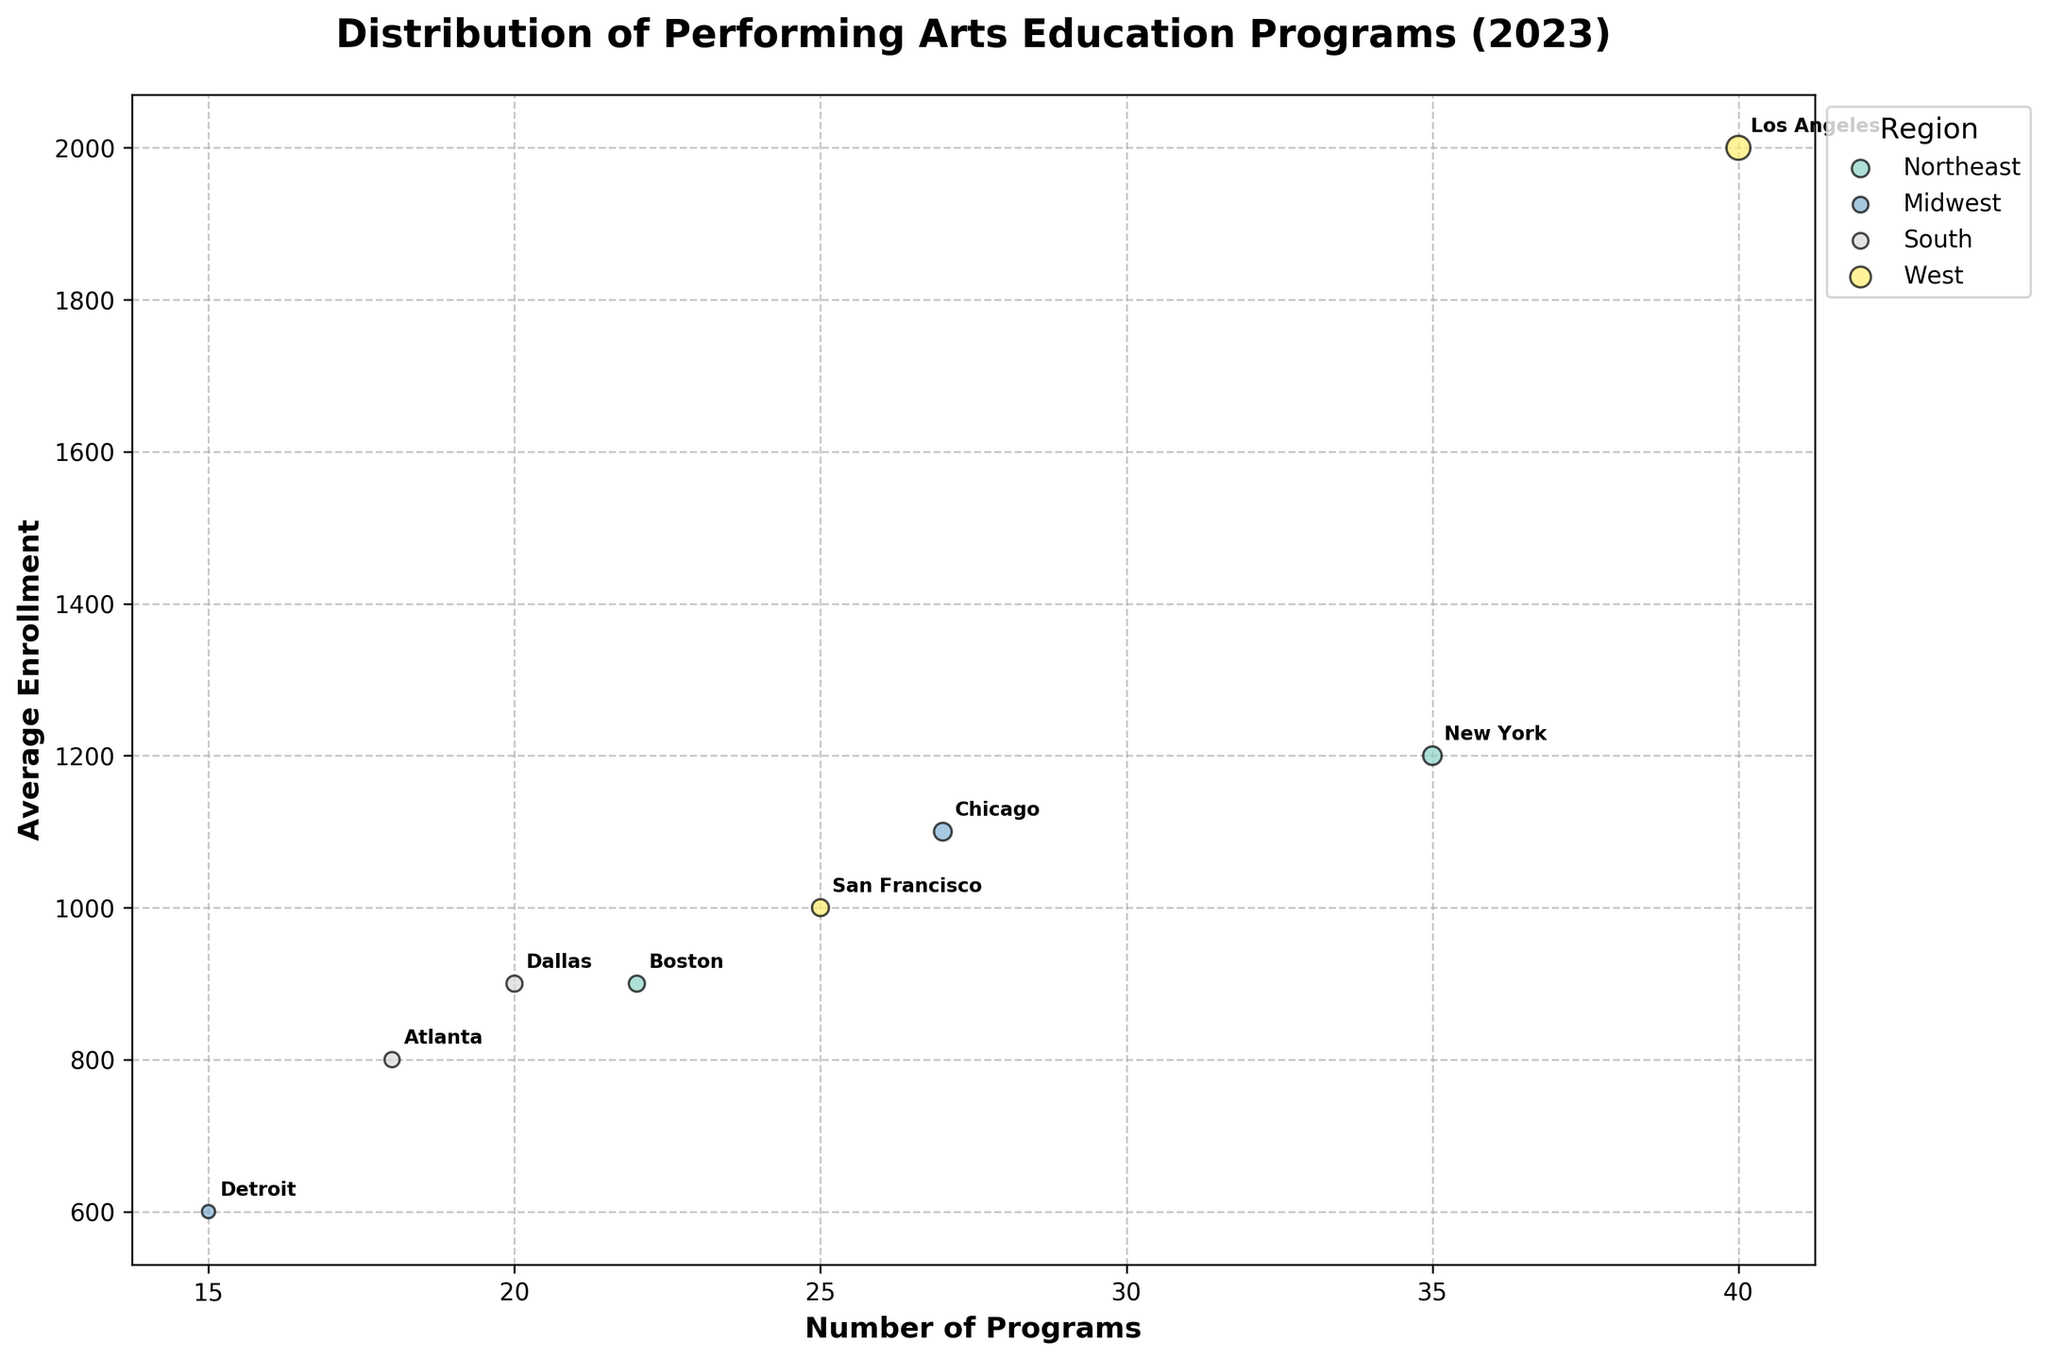what is the title of the plot? The title of the plot is typically printed on the top of the figure. For this plot, the title is located at the top center and reads "Distribution of Performing Arts Education Programs (2023)".
Answer: Distribution of Performing Arts Education Programs (2023) What are the axes labeled as? The x-axis is labeled as the "Number of Programs", and the y-axis is labeled as the "Average Enrollment". This information helps in interpreting what each axis represents.
Answer: Number of Programs, Average Enrollment Which city in the West region has the highest average enrollment? In the West region, there are two cities: Los Angeles and San Francisco. The average enrollment for Los Angeles is 2000, while for San Francisco, it is 1000. Therefore, Los Angeles has the highest average enrollment.
Answer: Los Angeles How many programs are in Boston, and what's the average enrollment? In the figure, Boston is annotated. By checking the position of the annotation related to its corresponding point, Boston has 22 programs and an average enrollment of 900.
Answer: 22 programs, 900 enrollment Which region has the city with the most significant number of programs? To find which region has the city with the most significant number of programs, compare the number of programs for each city. Los Angeles in the West region has the most programs, with 40.
Answer: West What is the total number of programs in the Northeast region? The cities in the Northeast region are New York and Boston. New York has 35 programs, and Boston has 22 programs. Therefore, the total number of programs in the Northeast region is 35 + 22 = 57.
Answer: 57 Which two cities have the closest average enrollment? By comparing the average enrollment values: New York (1200), Boston (900), Chicago (1100), Detroit (600), Atlanta (800), Dallas (900), Los Angeles (2000), San Francisco (1000), Boston and Dallas both have the average enrollment of 900.
Answer: Boston and Dallas What is the difference in average enrollment between New York and Detroit? New York has an average enrollment of 1200, whereas Detroit has an average enrollment of 600. The difference is calculated as 1200 - 600 = 600.
Answer: 600 Which city has the smallest number of programs, and how many programs are there? Among all cities, Detroit in the Midwest region has the smallest number of programs with a total of 15 programs.
Answer: Detroit, 15 programs Are there any cities in the figure from the South region that have a higher average enrollment than a city from the Midwest region? The cities in the South region are Atlanta (800 enrollment) and Dallas (900 enrollment). In the Midwest, cities are Chicago (1100 enrollment) and Detroit (600 enrollment). Comparing these, neither Atlanta nor Dallas has a higher average enrollment than Chicago. However, Dallas has a higher average enrollment than Detroit with 900 vs. 600.
Answer: Yes, Dallas compared to Detroit 